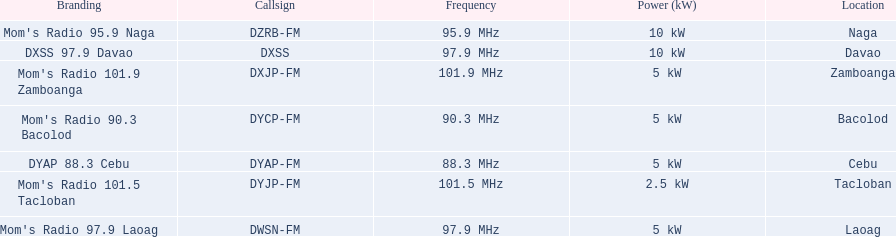What are the total number of radio stations on this list? 7. 